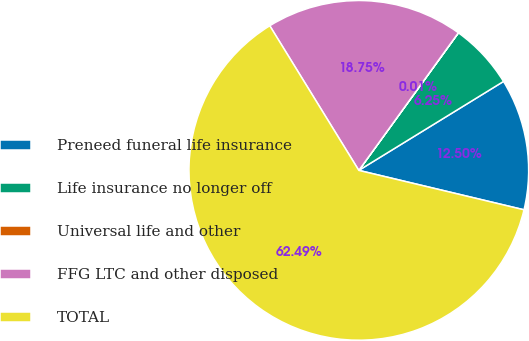Convert chart to OTSL. <chart><loc_0><loc_0><loc_500><loc_500><pie_chart><fcel>Preneed funeral life insurance<fcel>Life insurance no longer off<fcel>Universal life and other<fcel>FFG LTC and other disposed<fcel>TOTAL<nl><fcel>12.5%<fcel>6.25%<fcel>0.01%<fcel>18.75%<fcel>62.48%<nl></chart> 